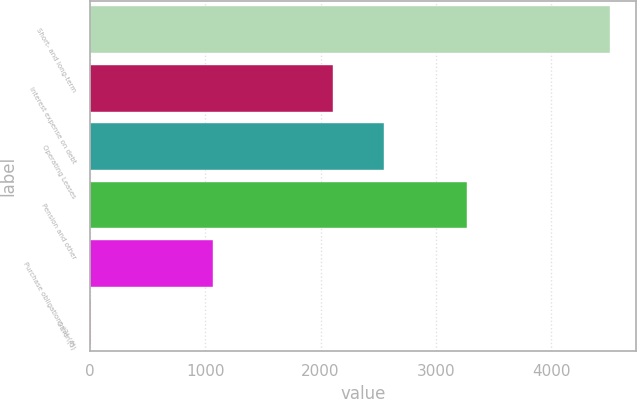<chart> <loc_0><loc_0><loc_500><loc_500><bar_chart><fcel>Short- and long-term<fcel>Interest expense on debt<fcel>Operating Leases<fcel>Pension and other<fcel>Purchase obligations (3) (4)<fcel>Other (5)<nl><fcel>4506<fcel>2104<fcel>2553.2<fcel>3267<fcel>1064<fcel>14<nl></chart> 